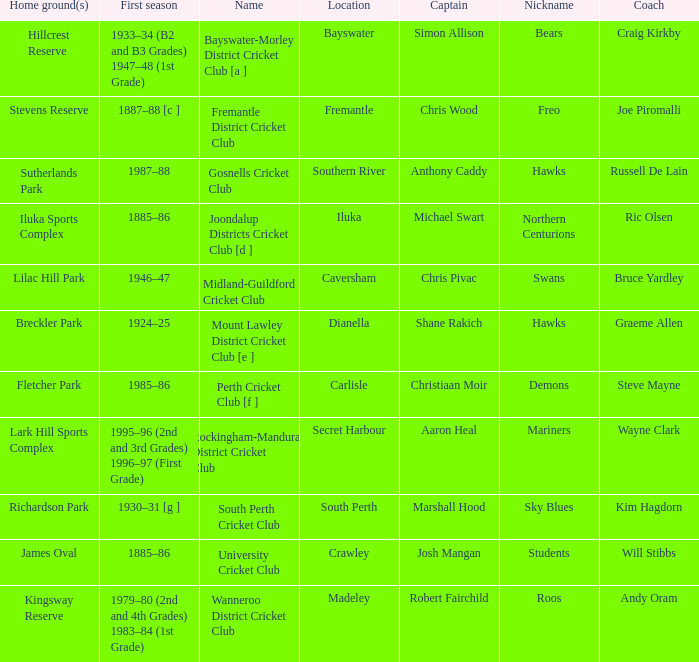For location Caversham, what is the name of the captain? Chris Pivac. 